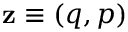<formula> <loc_0><loc_0><loc_500><loc_500>z \equiv ( q , p )</formula> 